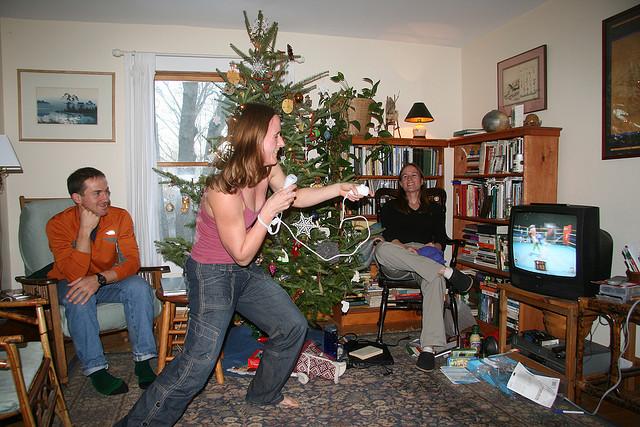What video game is on the television?
Quick response, please. Boxing. What kind of shoes is she wearing?
Concise answer only. None. What video game system are these people using?
Write a very short answer. Wii. Are there leaves on the trees outside the window?
Quick response, please. No. Whom is wearing slippers?
Keep it brief. Corner dude. 